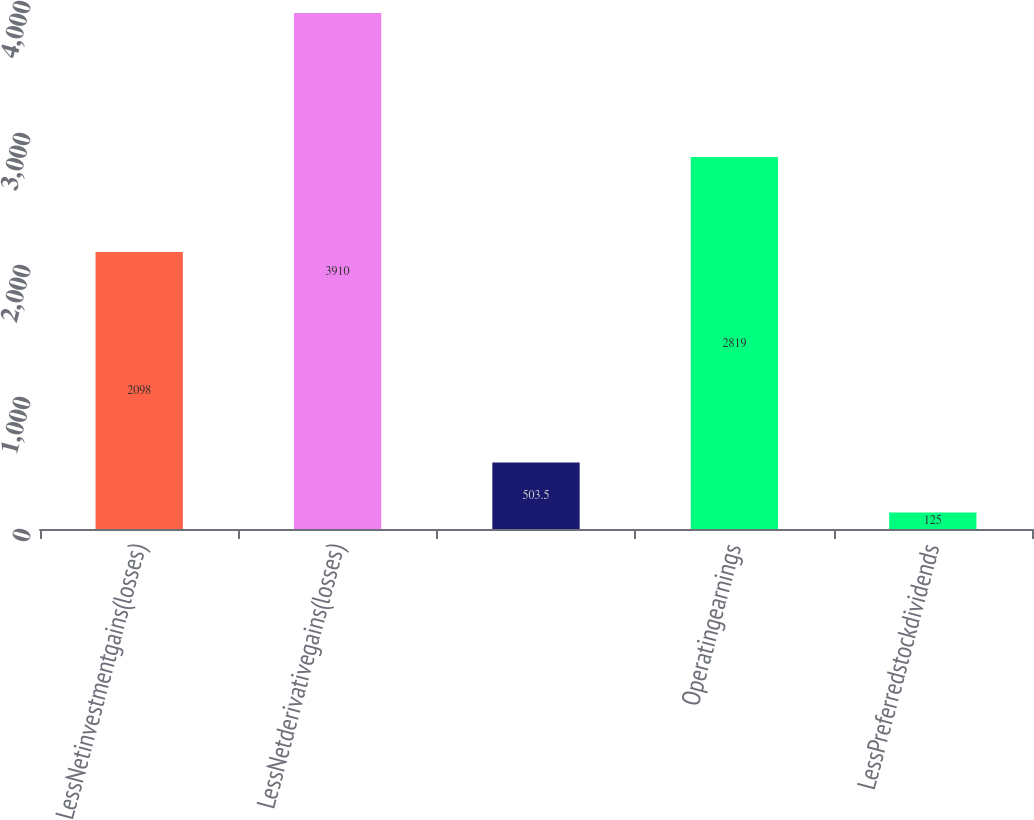Convert chart to OTSL. <chart><loc_0><loc_0><loc_500><loc_500><bar_chart><fcel>LessNetinvestmentgains(losses)<fcel>LessNetderivativegains(losses)<fcel>Unnamed: 2<fcel>Operatingearnings<fcel>LessPreferredstockdividends<nl><fcel>2098<fcel>3910<fcel>503.5<fcel>2819<fcel>125<nl></chart> 